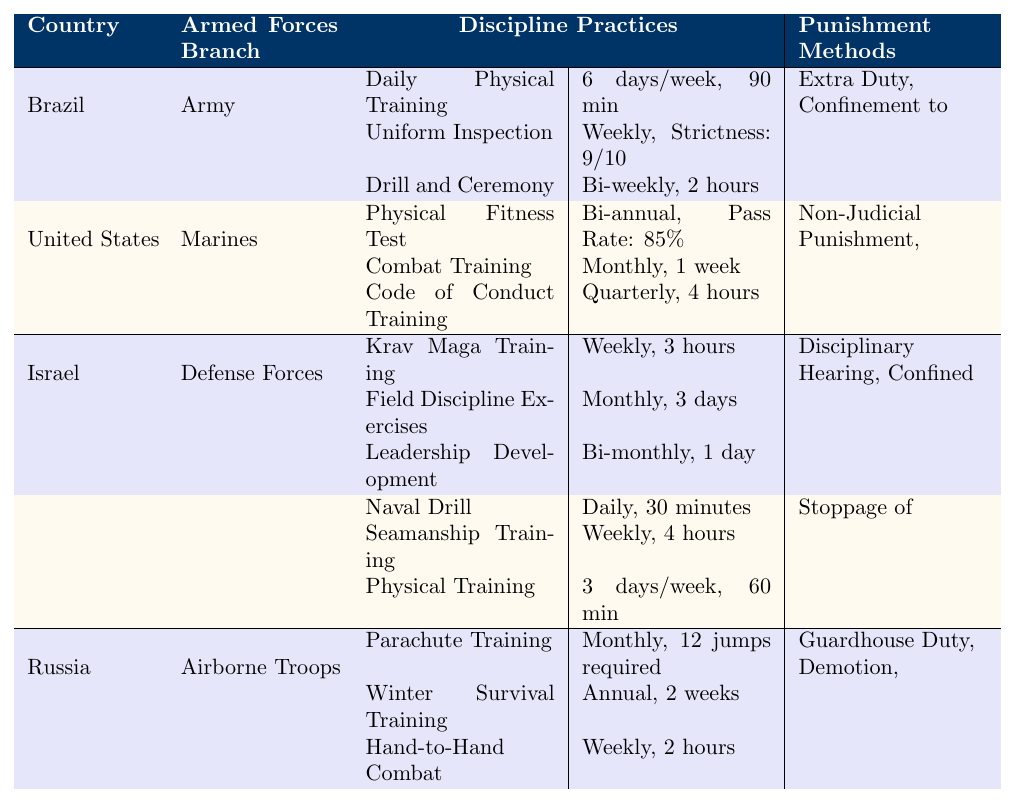What is the frequency of Daily Physical Training in Brazil? According to the table, Brazil has Daily Physical Training scheduled for 6 days a week.
Answer: 6 days/week What is the strictness level of Uniform Inspection in Brazil? The table indicates that the strictness level for Uniform Inspection in Brazil is 9 out of 10.
Answer: 9 How often do United States Marines participate in Combat Training? The table shows that the frequency of Combat Training for the United States Marines is once a month.
Answer: Monthly Which country has the longest duration for Physical Training? Upon examining the table, the United Kingdom has Physical Training lasting 60 minutes, while other countries have shorter durations for their training sessions.
Answer: United Kingdom Which punishment methods are applicable to the United States Armed Forces? The table lists three punishment methods for the United States: Non-Judicial Punishment, Court-Martial, and Administrative Separation.
Answer: Non-Judicial Punishment, Court-Martial, Administrative Separation Is Krav Maga Training performed weekly in Israel? Yes, the table confirms that Krav Maga Training is conducted every week in Israel.
Answer: Yes What are the punishment methods used in Russia? The table reveals that Russia uses Guardhouse Duty, Demotion, and Disciplinary Battalion as punishment methods.
Answer: Guardhouse Duty, Demotion, Disciplinary Battalion How many hours of training are involved in Leadership Development in Israel? The table states that Leadership Development takes place over a duration of 1 day (not specified in hours), but we can infer that it's part of a bi-monthly schedule.
Answer: 1 day What is the total duration of Naval Drill and Seamanship Training in the United Kingdom? The table specifies that Naval Drill lasts 30 minutes, while Seamanship Training lasts 4 hours. The total duration is 30 minutes + 4 hours = 4 hours and 30 minutes.
Answer: 4 hours and 30 minutes Which country has a physical fitness test that occurs bi-annually? The table shows that the United States Armed Forces conduct a Physical Fitness Test bi-annually.
Answer: United States Which country conducts Parachute Training monthly? The table mentions that Russia conducts Parachute Training every month, requiring 12 jumps per session.
Answer: Russia What is the average frequency of training for the Israeli Defense Forces? In Israel, the average frequency can be computed as: Weekly (Krav Maga) + Monthly (Field Discipline) + Bi-monthly (Leadership) = 1 (per week) + 1/4 (per week) + 1/8 (per week) = 1.375 weeks average = approximately every 2.2 weeks.
Answer: Approximately every 2.2 weeks Which military branch conducts Drill and Ceremony training bi-weekly? The table indicates that the Brazilian Army conducts Drill and Ceremony training every two weeks, which means it is a bi-weekly practice.
Answer: Brazilian Army Do all branches reported include a stringent inspection practice? Upon reviewing the table, Brazil and the United Kingdom mention inspection methods, while the United States, Israel, and Russia do not explicitly mention such a practice, indicating that not all branches have a stringent inspection practice.
Answer: No 